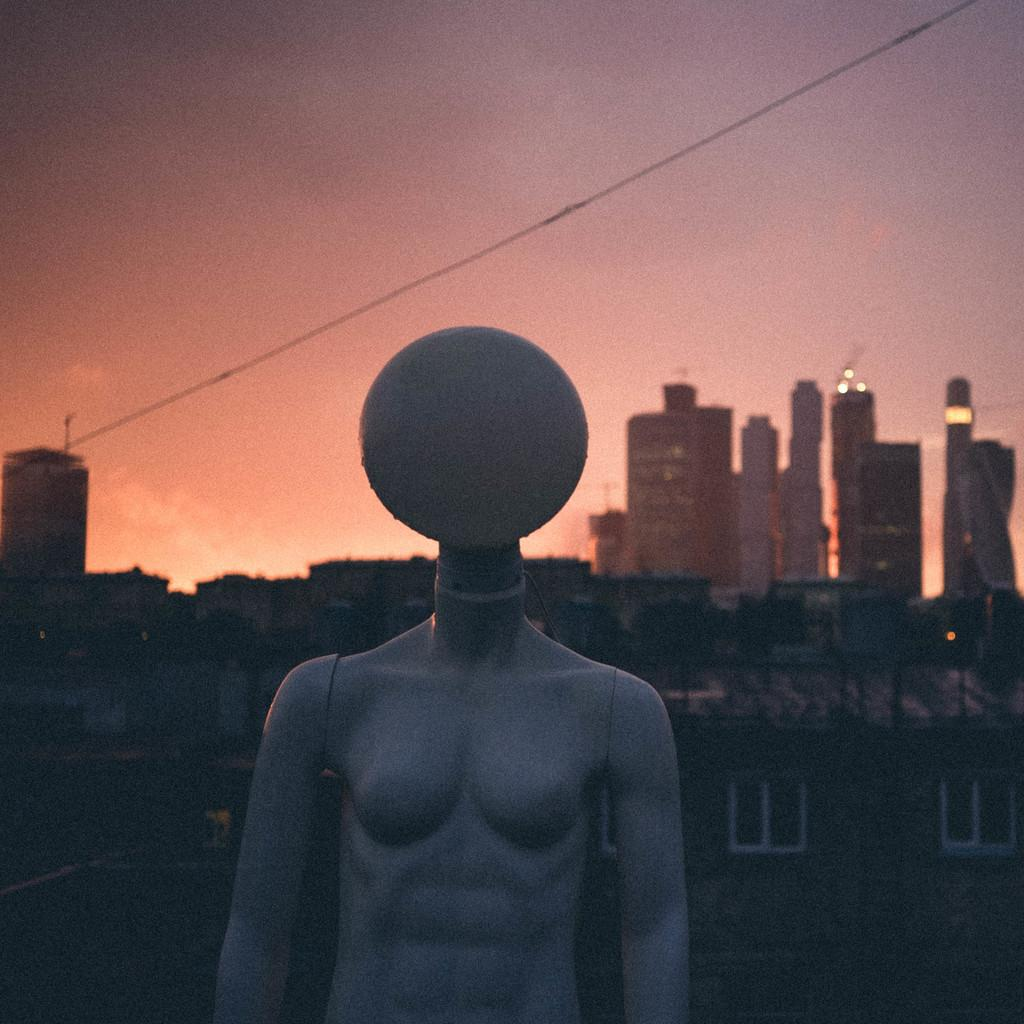What is located in the foreground of the image? There is a mannequin and a bulb in the foreground of the image. What can be seen in the background of the image? There are buildings, a cable, and the sky visible in the background of the image. How many deer can be seen in the image? There are no deer present in the image. What type of rake is being used in the operation depicted in the image? There is no operation or rake present in the image. 